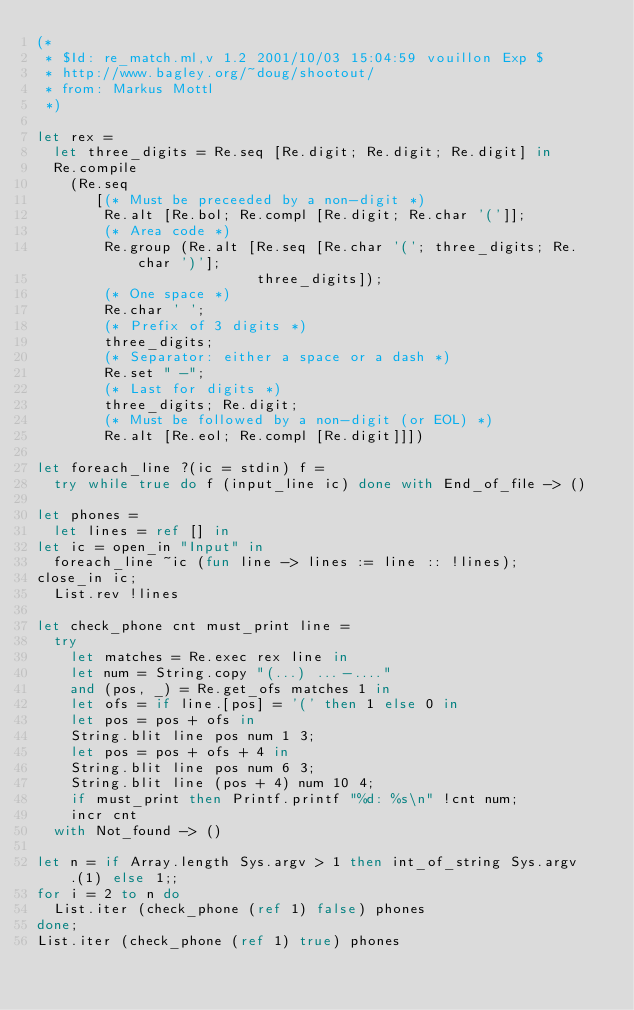Convert code to text. <code><loc_0><loc_0><loc_500><loc_500><_OCaml_>(*
 * $Id: re_match.ml,v 1.2 2001/10/03 15:04:59 vouillon Exp $
 * http://www.bagley.org/~doug/shootout/
 * from: Markus Mottl
 *)

let rex =
  let three_digits = Re.seq [Re.digit; Re.digit; Re.digit] in
  Re.compile
    (Re.seq
       [(* Must be preceeded by a non-digit *)
        Re.alt [Re.bol; Re.compl [Re.digit; Re.char '(']];
        (* Area code *)
        Re.group (Re.alt [Re.seq [Re.char '('; three_digits; Re.char ')'];
                          three_digits]);
        (* One space *)
        Re.char ' ';
        (* Prefix of 3 digits *)
        three_digits;
        (* Separator: either a space or a dash *)
        Re.set " -";
        (* Last for digits *)
        three_digits; Re.digit;
        (* Must be followed by a non-digit (or EOL) *)
        Re.alt [Re.eol; Re.compl [Re.digit]]])

let foreach_line ?(ic = stdin) f =
  try while true do f (input_line ic) done with End_of_file -> ()

let phones =
  let lines = ref [] in
let ic = open_in "Input" in
  foreach_line ~ic (fun line -> lines := line :: !lines);
close_in ic;
  List.rev !lines

let check_phone cnt must_print line =
  try
    let matches = Re.exec rex line in
    let num = String.copy "(...) ...-...."
    and (pos, _) = Re.get_ofs matches 1 in
    let ofs = if line.[pos] = '(' then 1 else 0 in
    let pos = pos + ofs in
    String.blit line pos num 1 3;
    let pos = pos + ofs + 4 in
    String.blit line pos num 6 3;
    String.blit line (pos + 4) num 10 4;
    if must_print then Printf.printf "%d: %s\n" !cnt num;
    incr cnt
  with Not_found -> ()

let n = if Array.length Sys.argv > 1 then int_of_string Sys.argv.(1) else 1;;
for i = 2 to n do
  List.iter (check_phone (ref 1) false) phones
done;
List.iter (check_phone (ref 1) true) phones
</code> 